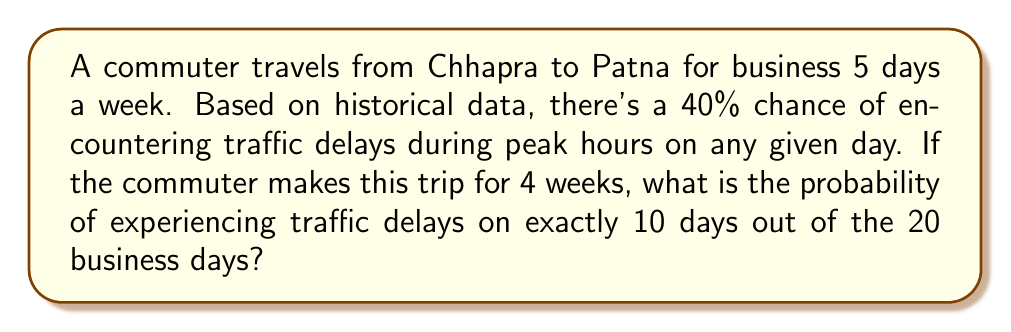What is the answer to this math problem? To solve this problem, we can use the binomial probability distribution:

1) Let $X$ be the number of days with traffic delays.
2) Each trip is an independent trial with probability $p = 0.4$ of encountering traffic delays.
3) We want to find $P(X = 10)$ for $n = 20$ trials.

The binomial probability formula is:

$$P(X = k) = \binom{n}{k} p^k (1-p)^{n-k}$$

Where:
- $n$ is the number of trials (20 days)
- $k$ is the number of successes (10 days with delays)
- $p$ is the probability of success on each trial (0.4)

Let's calculate step by step:

1) First, calculate the binomial coefficient:
   $$\binom{20}{10} = \frac{20!}{10!(20-10)!} = 184,756$$

2) Now, let's substitute all values into the formula:
   $$P(X = 10) = 184,756 \cdot (0.4)^{10} \cdot (1-0.4)^{20-10}$$

3) Simplify:
   $$P(X = 10) = 184,756 \cdot (0.4)^{10} \cdot (0.6)^{10}$$

4) Calculate:
   $$P(X = 10) \approx 0.1662$$

Therefore, the probability of experiencing traffic delays on exactly 10 out of 20 business days is approximately 0.1662 or 16.62%.
Answer: 0.1662 